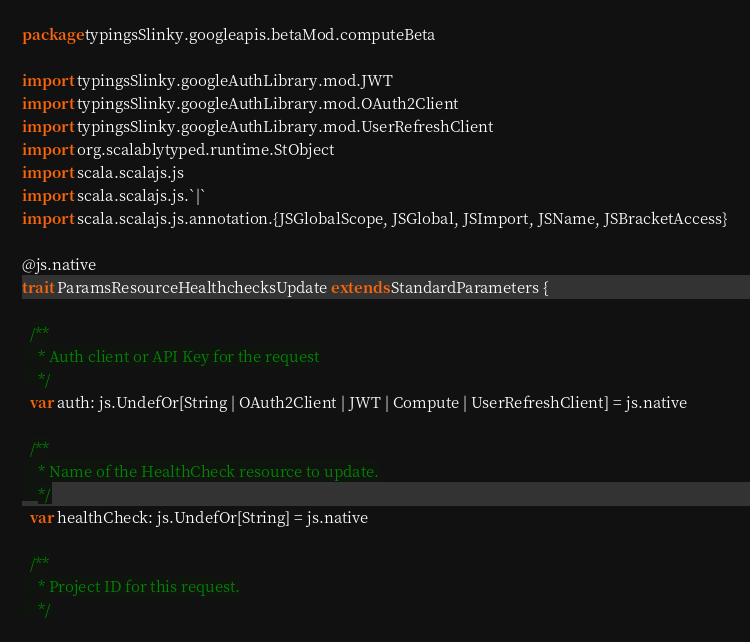Convert code to text. <code><loc_0><loc_0><loc_500><loc_500><_Scala_>package typingsSlinky.googleapis.betaMod.computeBeta

import typingsSlinky.googleAuthLibrary.mod.JWT
import typingsSlinky.googleAuthLibrary.mod.OAuth2Client
import typingsSlinky.googleAuthLibrary.mod.UserRefreshClient
import org.scalablytyped.runtime.StObject
import scala.scalajs.js
import scala.scalajs.js.`|`
import scala.scalajs.js.annotation.{JSGlobalScope, JSGlobal, JSImport, JSName, JSBracketAccess}

@js.native
trait ParamsResourceHealthchecksUpdate extends StandardParameters {
  
  /**
    * Auth client or API Key for the request
    */
  var auth: js.UndefOr[String | OAuth2Client | JWT | Compute | UserRefreshClient] = js.native
  
  /**
    * Name of the HealthCheck resource to update.
    */
  var healthCheck: js.UndefOr[String] = js.native
  
  /**
    * Project ID for this request.
    */</code> 